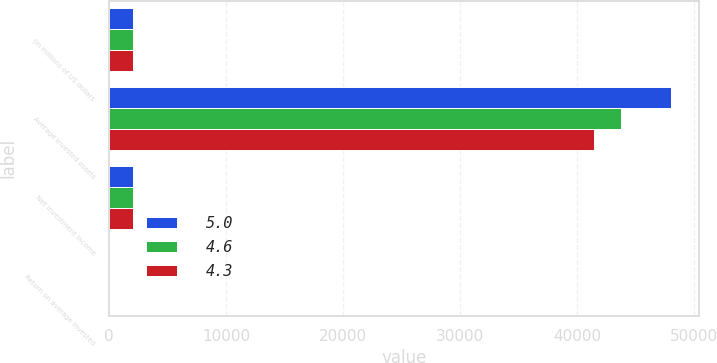Convert chart to OTSL. <chart><loc_0><loc_0><loc_500><loc_500><stacked_bar_chart><ecel><fcel>(in millions of US dollars<fcel>Average invested assets<fcel>Net investment income<fcel>Return on average invested<nl><fcel>5<fcel>2010<fcel>48044<fcel>2070<fcel>4.3<nl><fcel>4.6<fcel>2009<fcel>43767<fcel>2031<fcel>4.6<nl><fcel>4.3<fcel>2008<fcel>41502<fcel>2062<fcel>5<nl></chart> 